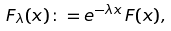<formula> <loc_0><loc_0><loc_500><loc_500>F _ { \lambda } ( x ) \colon = e ^ { - \lambda x } \, F ( x ) ,</formula> 